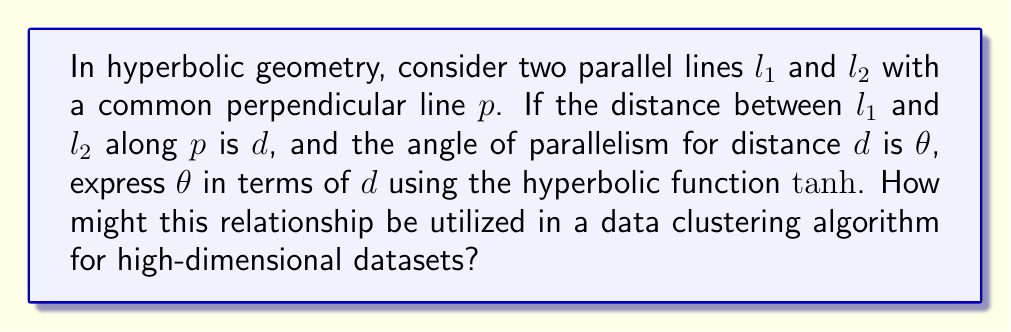Can you solve this math problem? 1. In hyperbolic geometry, the angle of parallelism $\theta$ for a distance $d$ is given by the formula:

   $$\theta = 2 \arctan(e^{-d})$$

2. We need to express this in terms of $\tanh$. Recall that:

   $$\tanh(x) = \frac{e^x - e^{-x}}{e^x + e^{-x}}$$

3. Let's consider $\tanh(\frac{d}{2})$:

   $$\tanh(\frac{d}{2}) = \frac{e^{d/2} - e^{-d/2}}{e^{d/2} + e^{-d/2}}$$

4. Multiply numerator and denominator by $e^{d/2}$:

   $$\tanh(\frac{d}{2}) = \frac{e^d - 1}{e^d + 1}$$

5. Now, let's manipulate this:

   $$1 - \tanh(\frac{d}{2}) = \frac{(e^d + 1) - (e^d - 1)}{e^d + 1} = \frac{2}{e^d + 1}$$

6. Therefore:

   $$\frac{1}{1 - \tanh(\frac{d}{2})} = \frac{e^d + 1}{2}$$

7. Subtracting 1 from both sides:

   $$\frac{1}{1 - \tanh(\frac{d}{2})} - 1 = \frac{e^d - 1}{2}$$

8. Simplifying the left side:

   $$\frac{\tanh(\frac{d}{2})}{1 - \tanh(\frac{d}{2})} = \frac{e^d - 1}{2}$$

9. Taking the reciprocal of both sides:

   $$\frac{2}{\tanh(\frac{d}{2})} = \frac{e^d + 1}{e^d - 1}$$

10. The right side is equal to $\cot(\frac{\theta}{2})$, so:

    $$\cot(\frac{\theta}{2}) = \frac{2}{\tanh(\frac{d}{2})}$$

11. Taking the arctangent of both sides:

    $$\frac{\theta}{2} = \arctan(\frac{\tanh(\frac{d}{2})}{2})$$

12. Therefore:

    $$\theta = 2\arctan(\frac{\tanh(\frac{d}{2})}{2})$$

This relationship can be utilized in data clustering algorithms for high-dimensional datasets by:

a) Mapping high-dimensional data to hyperbolic space, where the distance between points naturally increases exponentially as you move away from the origin.

b) Using the angle of parallelism to define similarity thresholds between data points, adapting to the increasing sparsity of data in higher dimensions.

c) Implementing clustering algorithms that exploit the hierarchical structure naturally present in hyperbolic space, potentially leading to more efficient and accurate clustering of high-dimensional data.
Answer: $\theta = 2\arctan(\frac{\tanh(\frac{d}{2})}{2})$ 